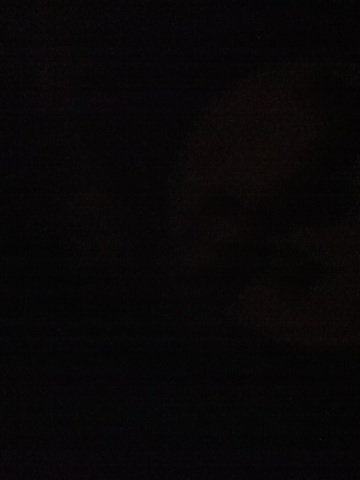Given this darkness, can you create a narrative about finding a hidden treasure in this scene? In the depths of the impenetrable darkness, an adventurous soul ventures forth, guided only by a battered map handed down through generations. The air grows colder, and the sense of foreboding deepens with each step. Suddenly, a faint glint catches their eye - the hilt of a sword, which appears to float in the air, leading to a hidden chamber. Following the sword's path, they discover an ancient vault carved into the obsidian rock, its surface adorned with mysterious symbols. As they decipher the symbols, the vault opens, revealing a treasure of unimaginable value: artifacts of lost civilizations, precious gems emitting their own light, and scrolls containing secrets that could alter the course of history.  This image might depict an abandoned area. Can you provide a short description? The pitch darkness of the image suggests it could be the remains of an abandoned area. The silence is palpable, with shadows hinting at structures long forsaken. An occasional echo of the past seems to linger in the air, telling tales of a once-vibrant place now claimed by time and obscurity. 